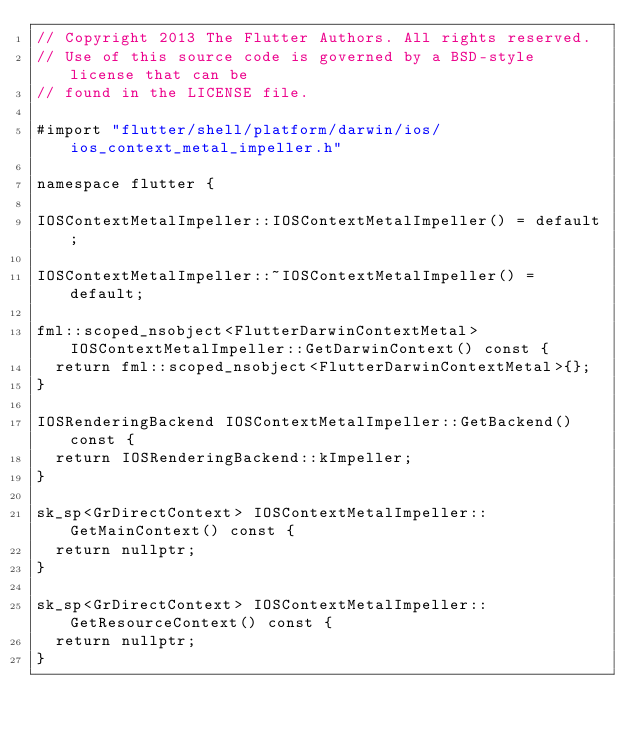Convert code to text. <code><loc_0><loc_0><loc_500><loc_500><_ObjectiveC_>// Copyright 2013 The Flutter Authors. All rights reserved.
// Use of this source code is governed by a BSD-style license that can be
// found in the LICENSE file.

#import "flutter/shell/platform/darwin/ios/ios_context_metal_impeller.h"

namespace flutter {

IOSContextMetalImpeller::IOSContextMetalImpeller() = default;

IOSContextMetalImpeller::~IOSContextMetalImpeller() = default;

fml::scoped_nsobject<FlutterDarwinContextMetal> IOSContextMetalImpeller::GetDarwinContext() const {
  return fml::scoped_nsobject<FlutterDarwinContextMetal>{};
}

IOSRenderingBackend IOSContextMetalImpeller::GetBackend() const {
  return IOSRenderingBackend::kImpeller;
}

sk_sp<GrDirectContext> IOSContextMetalImpeller::GetMainContext() const {
  return nullptr;
}

sk_sp<GrDirectContext> IOSContextMetalImpeller::GetResourceContext() const {
  return nullptr;
}
</code> 